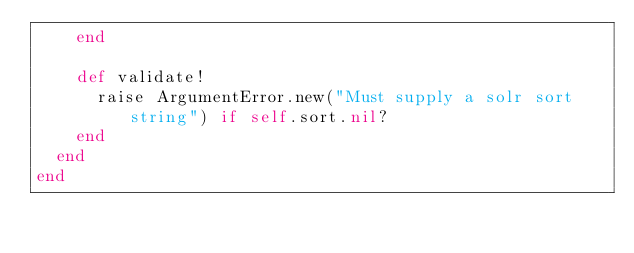<code> <loc_0><loc_0><loc_500><loc_500><_Ruby_>    end

    def validate!
      raise ArgumentError.new("Must supply a solr sort string") if self.sort.nil?
    end
  end
end
</code> 